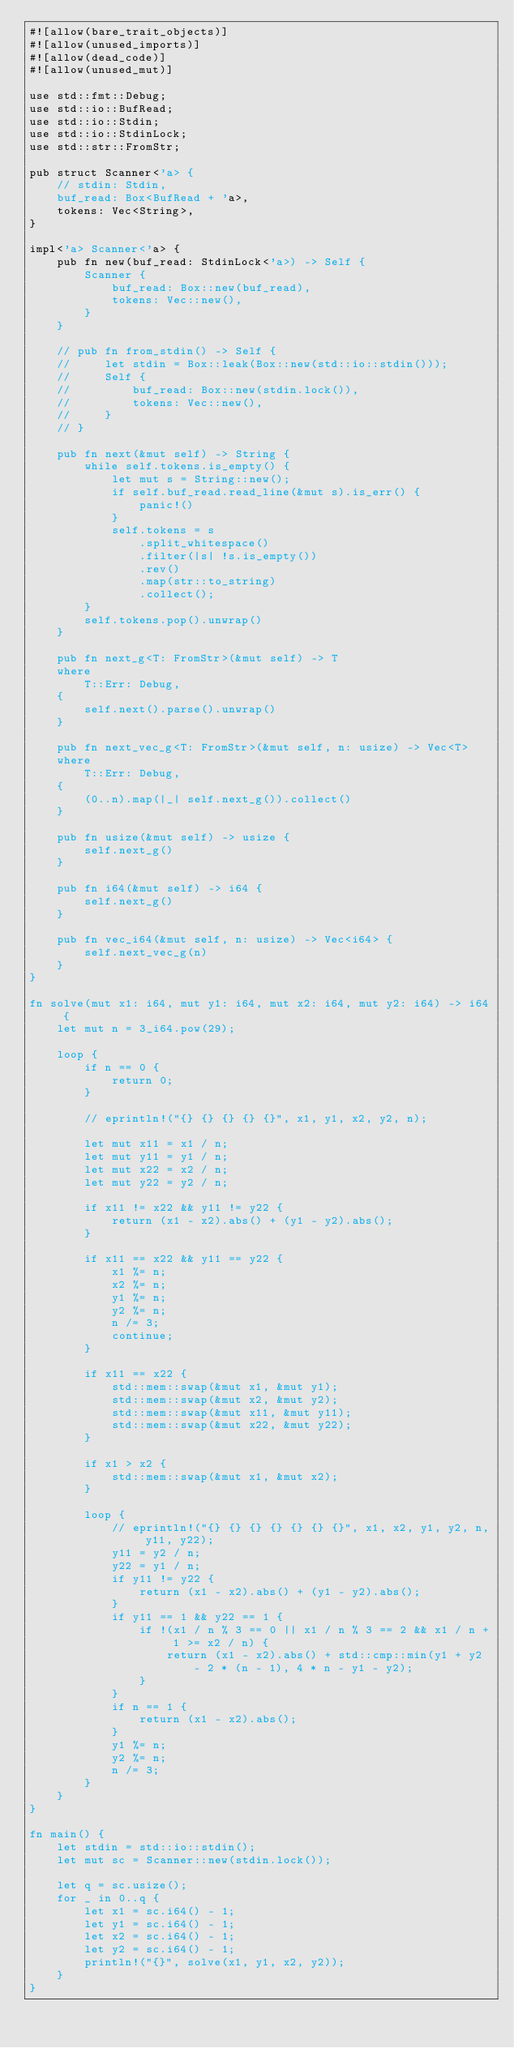Convert code to text. <code><loc_0><loc_0><loc_500><loc_500><_Rust_>#![allow(bare_trait_objects)]
#![allow(unused_imports)]
#![allow(dead_code)]
#![allow(unused_mut)]

use std::fmt::Debug;
use std::io::BufRead;
use std::io::Stdin;
use std::io::StdinLock;
use std::str::FromStr;

pub struct Scanner<'a> {
    // stdin: Stdin,
    buf_read: Box<BufRead + 'a>,
    tokens: Vec<String>,
}

impl<'a> Scanner<'a> {
    pub fn new(buf_read: StdinLock<'a>) -> Self {
        Scanner {
            buf_read: Box::new(buf_read),
            tokens: Vec::new(),
        }
    }

    // pub fn from_stdin() -> Self {
    //     let stdin = Box::leak(Box::new(std::io::stdin()));
    //     Self {
    //         buf_read: Box::new(stdin.lock()),
    //         tokens: Vec::new(),
    //     }
    // }

    pub fn next(&mut self) -> String {
        while self.tokens.is_empty() {
            let mut s = String::new();
            if self.buf_read.read_line(&mut s).is_err() {
                panic!()
            }
            self.tokens = s
                .split_whitespace()
                .filter(|s| !s.is_empty())
                .rev()
                .map(str::to_string)
                .collect();
        }
        self.tokens.pop().unwrap()
    }

    pub fn next_g<T: FromStr>(&mut self) -> T
    where
        T::Err: Debug,
    {
        self.next().parse().unwrap()
    }

    pub fn next_vec_g<T: FromStr>(&mut self, n: usize) -> Vec<T>
    where
        T::Err: Debug,
    {
        (0..n).map(|_| self.next_g()).collect()
    }

    pub fn usize(&mut self) -> usize {
        self.next_g()
    }

    pub fn i64(&mut self) -> i64 {
        self.next_g()
    }

    pub fn vec_i64(&mut self, n: usize) -> Vec<i64> {
        self.next_vec_g(n)
    }
}

fn solve(mut x1: i64, mut y1: i64, mut x2: i64, mut y2: i64) -> i64 {
    let mut n = 3_i64.pow(29);

    loop {
        if n == 0 {
            return 0;
        }

        // eprintln!("{} {} {} {} {}", x1, y1, x2, y2, n);

        let mut x11 = x1 / n;
        let mut y11 = y1 / n;
        let mut x22 = x2 / n;
        let mut y22 = y2 / n;

        if x11 != x22 && y11 != y22 {
            return (x1 - x2).abs() + (y1 - y2).abs();
        }

        if x11 == x22 && y11 == y22 {
            x1 %= n;
            x2 %= n;
            y1 %= n;
            y2 %= n;
            n /= 3;
            continue;
        }

        if x11 == x22 {
            std::mem::swap(&mut x1, &mut y1);
            std::mem::swap(&mut x2, &mut y2);
            std::mem::swap(&mut x11, &mut y11);
            std::mem::swap(&mut x22, &mut y22);
        }

        if x1 > x2 {
            std::mem::swap(&mut x1, &mut x2);
        }

        loop {
            // eprintln!("{} {} {} {} {} {} {}", x1, x2, y1, y2, n, y11, y22);
            y11 = y2 / n;
            y22 = y1 / n;
            if y11 != y22 {
                return (x1 - x2).abs() + (y1 - y2).abs();
            }
            if y11 == 1 && y22 == 1 {
                if !(x1 / n % 3 == 0 || x1 / n % 3 == 2 && x1 / n + 1 >= x2 / n) {
                    return (x1 - x2).abs() + std::cmp::min(y1 + y2 - 2 * (n - 1), 4 * n - y1 - y2);
                }
            }
            if n == 1 {
                return (x1 - x2).abs();
            }
            y1 %= n;
            y2 %= n;
            n /= 3;
        }
    }
}

fn main() {
    let stdin = std::io::stdin();
    let mut sc = Scanner::new(stdin.lock());

    let q = sc.usize();
    for _ in 0..q {
        let x1 = sc.i64() - 1;
        let y1 = sc.i64() - 1;
        let x2 = sc.i64() - 1;
        let y2 = sc.i64() - 1;
        println!("{}", solve(x1, y1, x2, y2));
    }
}
</code> 